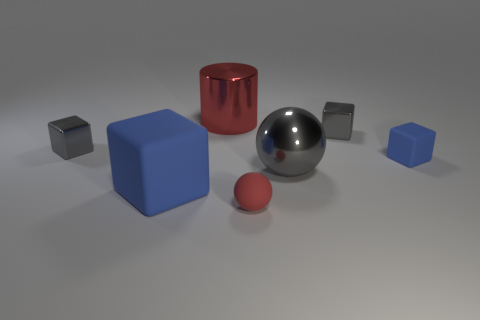What can you infer about the material characteristics of the objects? The silver sphere and the red cylinder have reflective surfaces, suggesting they're made of materials like polished metal or plastic. The matte objects, such as the blue cubes and the small red sphere, likely consist of a non-reflective material like rubber or unpolished plastic. How does the texture of these objects influence their function or use? Reflective objects may be designed to attract attention or signify importance, often used in decorative or signaling applications. Matte objects, with their non-reflective surfaces, are better suited to practical uses where glare or reflection may be undesirable, such as in handling or tooling components. 